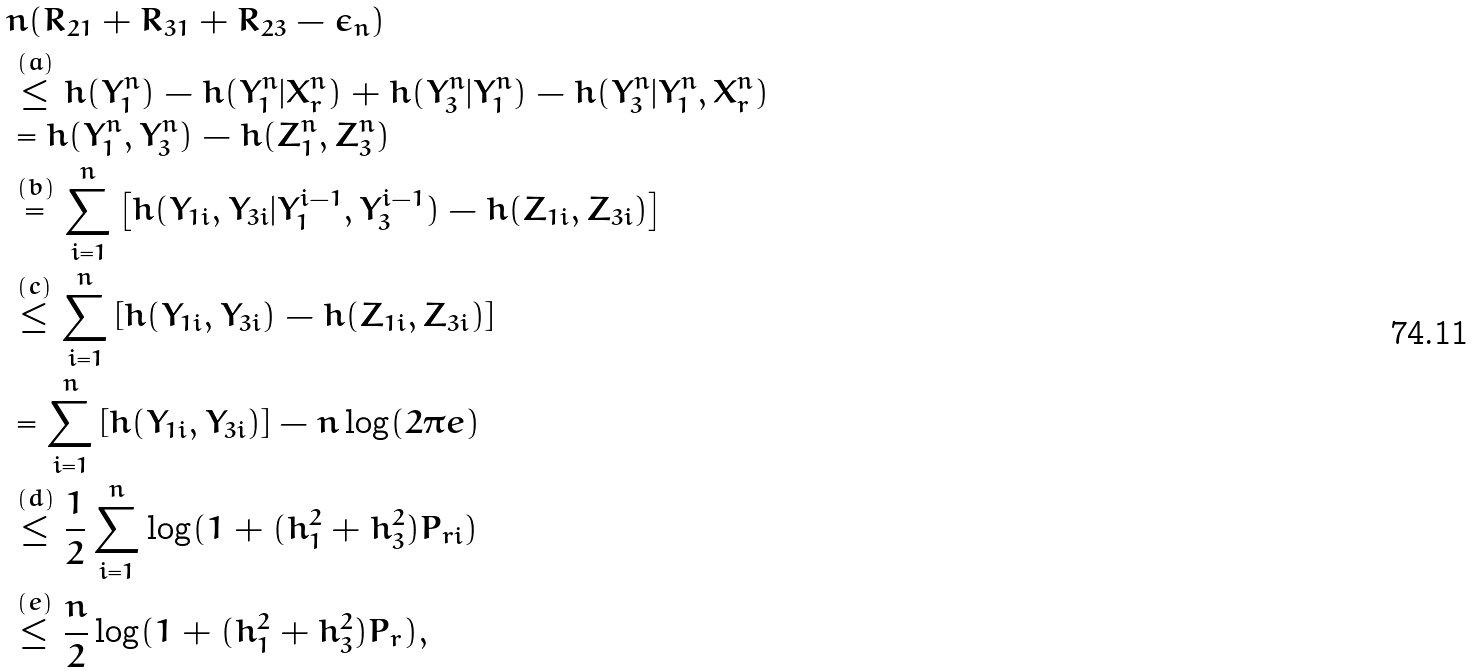<formula> <loc_0><loc_0><loc_500><loc_500>& n ( R _ { 2 1 } + R _ { 3 1 } + R _ { 2 3 } - \epsilon _ { n } ) \\ & \stackrel { ( a ) } { \leq } h ( Y _ { 1 } ^ { n } ) - h ( Y _ { 1 } ^ { n } | X _ { r } ^ { n } ) + h ( Y _ { 3 } ^ { n } | Y _ { 1 } ^ { n } ) - h ( Y _ { 3 } ^ { n } | Y _ { 1 } ^ { n } , X _ { r } ^ { n } ) \\ & = h ( Y _ { 1 } ^ { n } , Y _ { 3 } ^ { n } ) - h ( Z _ { 1 } ^ { n } , Z _ { 3 } ^ { n } ) \\ & \stackrel { ( b ) } { = } \sum _ { i = 1 } ^ { n } \left [ h ( Y _ { 1 i } , Y _ { 3 i } | Y _ { 1 } ^ { i - 1 } , Y _ { 3 } ^ { i - 1 } ) - h ( Z _ { 1 i } , Z _ { 3 i } ) \right ] \\ & \stackrel { ( c ) } { \leq } \sum _ { i = 1 } ^ { n } \left [ h ( Y _ { 1 i } , Y _ { 3 i } ) - h ( Z _ { 1 i } , Z _ { 3 i } ) \right ] \\ & = \sum _ { i = 1 } ^ { n } \left [ h ( Y _ { 1 i } , Y _ { 3 i } ) \right ] - n \log ( 2 \pi e ) \\ & \stackrel { ( d ) } { \leq } \frac { 1 } { 2 } \sum _ { i = 1 } ^ { n } \log ( 1 + ( h _ { 1 } ^ { 2 } + h _ { 3 } ^ { 2 } ) P _ { r i } ) \\ & \stackrel { ( e ) } { \leq } \frac { n } { 2 } \log ( 1 + ( h _ { 1 } ^ { 2 } + h _ { 3 } ^ { 2 } ) P _ { r } ) ,</formula> 